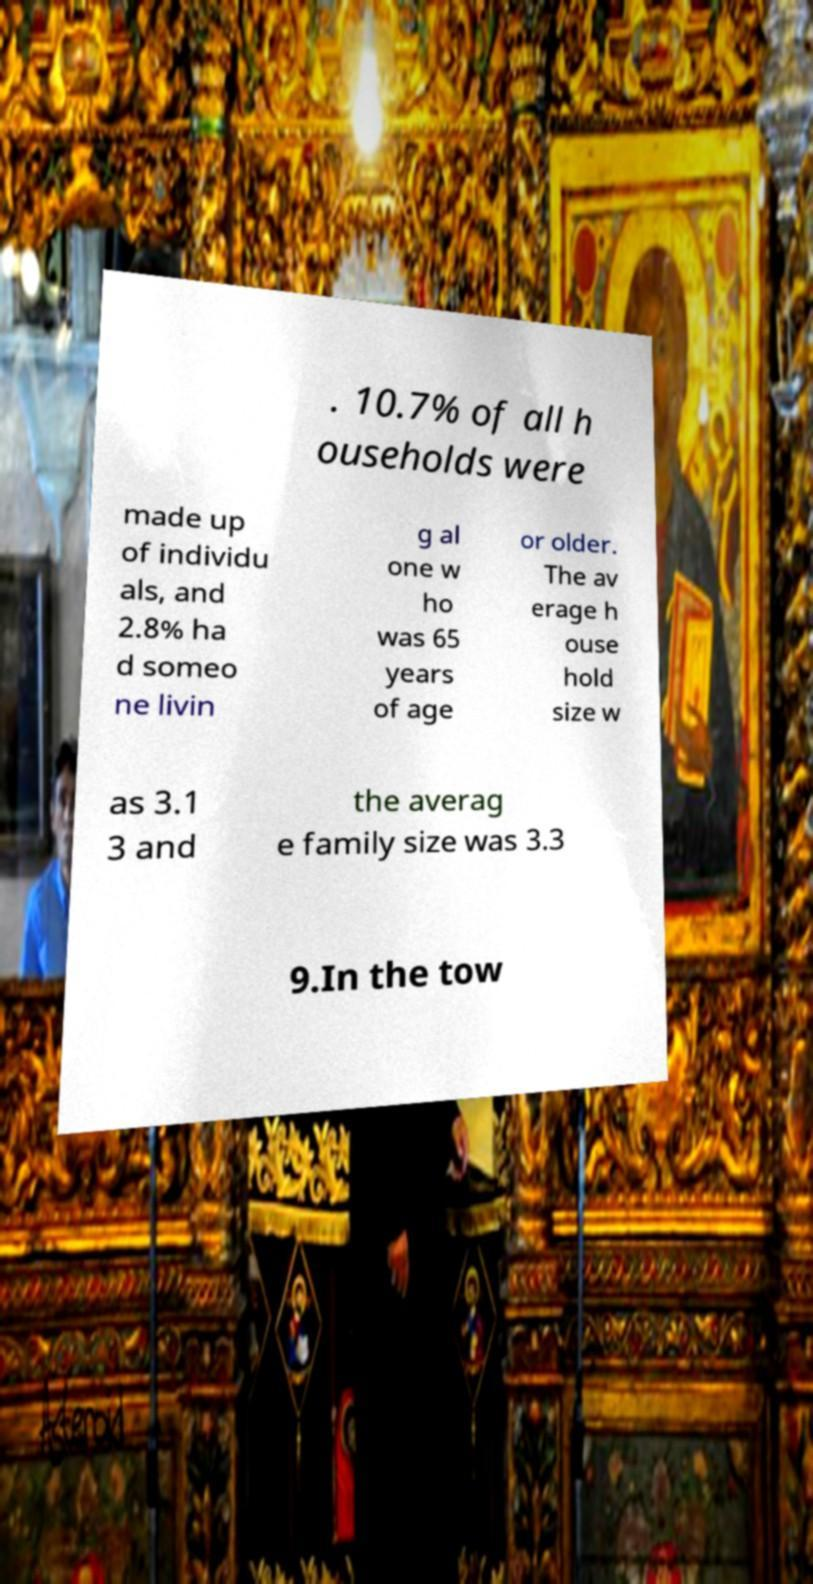Please read and relay the text visible in this image. What does it say? . 10.7% of all h ouseholds were made up of individu als, and 2.8% ha d someo ne livin g al one w ho was 65 years of age or older. The av erage h ouse hold size w as 3.1 3 and the averag e family size was 3.3 9.In the tow 